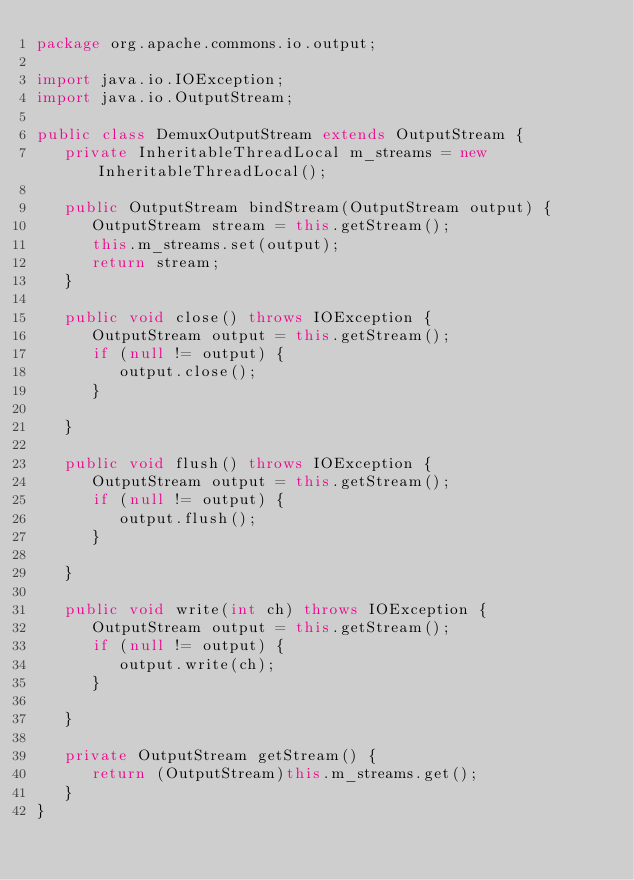<code> <loc_0><loc_0><loc_500><loc_500><_Java_>package org.apache.commons.io.output;

import java.io.IOException;
import java.io.OutputStream;

public class DemuxOutputStream extends OutputStream {
   private InheritableThreadLocal m_streams = new InheritableThreadLocal();

   public OutputStream bindStream(OutputStream output) {
      OutputStream stream = this.getStream();
      this.m_streams.set(output);
      return stream;
   }

   public void close() throws IOException {
      OutputStream output = this.getStream();
      if (null != output) {
         output.close();
      }

   }

   public void flush() throws IOException {
      OutputStream output = this.getStream();
      if (null != output) {
         output.flush();
      }

   }

   public void write(int ch) throws IOException {
      OutputStream output = this.getStream();
      if (null != output) {
         output.write(ch);
      }

   }

   private OutputStream getStream() {
      return (OutputStream)this.m_streams.get();
   }
}
</code> 